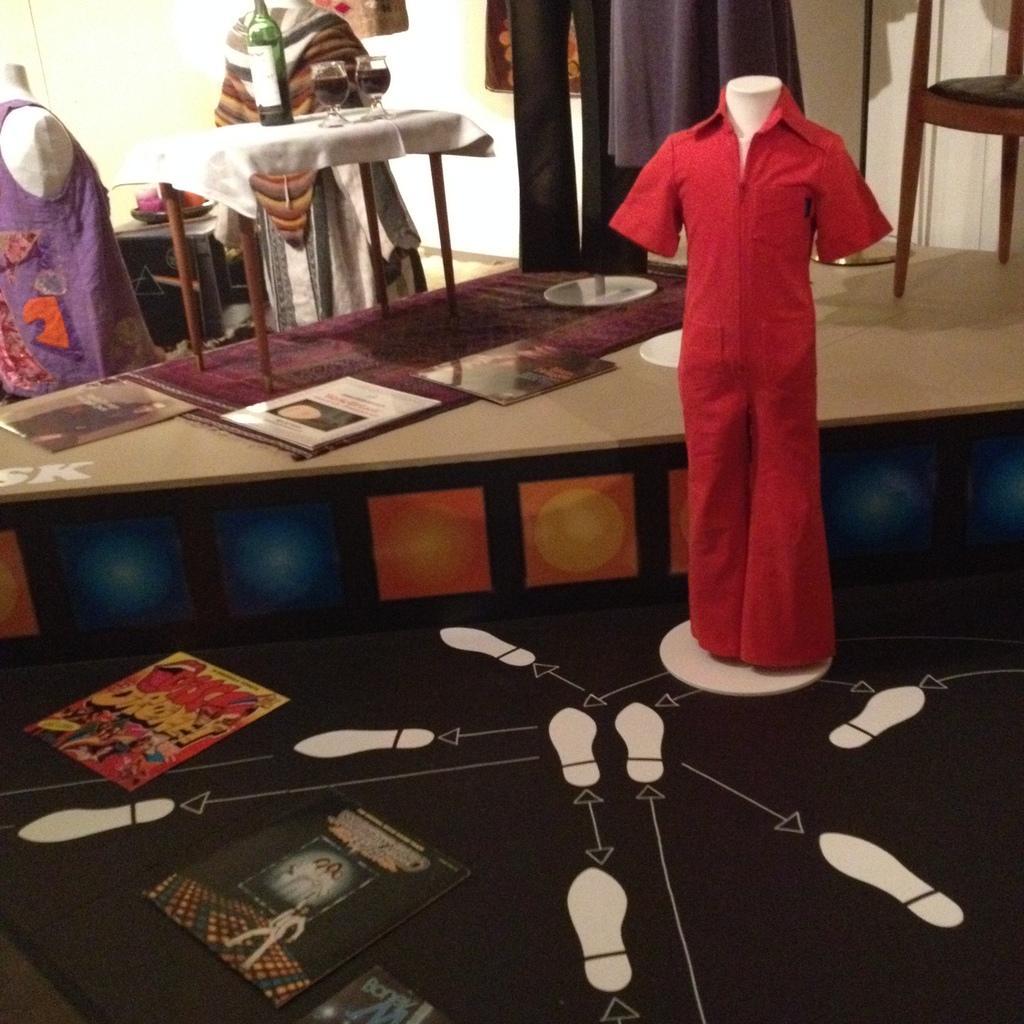Describe this image in one or two sentences. There are three mannequin in the image. In the right hand side the mannequin is wearing a red dress. On the left top corner the mannequin is wearing a violet dress, beside it the mannequin is wearing a white dress. In front of the mannequin there is a table. The table is having a tablecloth. On the table there is bottle and two glasses filled with wine. Under the table there is a mat. Some books are on the mat. There are dresses. In the right top corner there is a chair. There are few more books on the floor. 